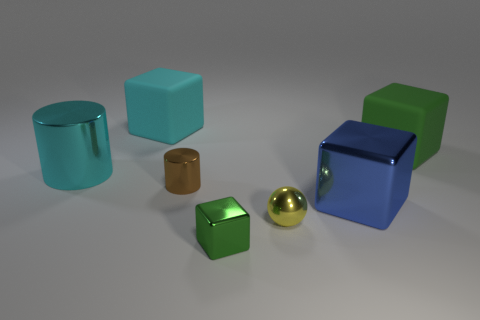Add 2 large blue cubes. How many objects exist? 9 Subtract all cylinders. How many objects are left? 5 Add 3 tiny cylinders. How many tiny cylinders exist? 4 Subtract 0 green cylinders. How many objects are left? 7 Subtract all rubber objects. Subtract all blue matte objects. How many objects are left? 5 Add 5 blue blocks. How many blue blocks are left? 6 